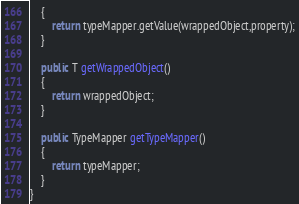<code> <loc_0><loc_0><loc_500><loc_500><_Java_>    {
        return typeMapper.getValue(wrappedObject,property);
    }

    public T getWrappedObject()
    {
        return wrappedObject;
    }

    public TypeMapper getTypeMapper()
    {
        return typeMapper;
    }
}
</code> 